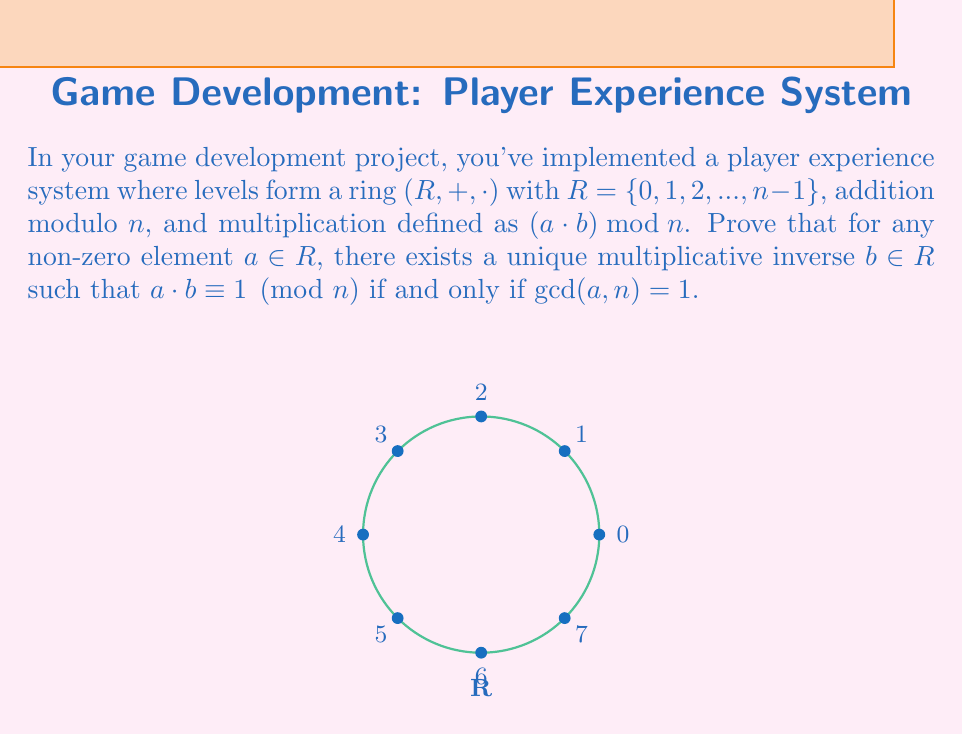Could you help me with this problem? Let's prove this step-by-step:

1) First, we'll prove the forward direction: if $a$ has a multiplicative inverse, then $\gcd(a, n) = 1$.

   Assume $b$ is the multiplicative inverse of $a$. Then:
   
   $a \cdot b \equiv 1 \pmod{n}$
   
   This means there exists an integer $k$ such that:
   
   $ab = kn + 1$

   Rearranging:
   
   $ab - kn = 1$

   This is a linear combination of $a$ and $n$ equaling 1, which means $\gcd(a, n) = 1$.

2) Now, let's prove the reverse direction: if $\gcd(a, n) = 1$, then $a$ has a multiplicative inverse.

   If $\gcd(a, n) = 1$, by Bézout's identity, there exist integers $x$ and $y$ such that:
   
   $ax + ny = 1$

   Taking both sides modulo $n$:
   
   $ax \equiv 1 \pmod{n}$

   This means $x \bmod n$ is the multiplicative inverse of $a$ in $R$.

3) For uniqueness, assume $b$ and $c$ are both multiplicative inverses of $a$. Then:

   $ab \equiv 1 \pmod{n}$ and $ac \equiv 1 \pmod{n}$

   Multiplying the second equation by $b$:

   $abc \equiv b \pmod{n}$

   But $ab \equiv 1 \pmod{n}$, so:

   $c \equiv b \pmod{n}$

   Therefore, the multiplicative inverse is unique in $R$.

Thus, we have proved that a non-zero element $a$ in $R$ has a unique multiplicative inverse if and only if $\gcd(a, n) = 1$.
Answer: $a$ has a unique multiplicative inverse $\iff \gcd(a, n) = 1$ 